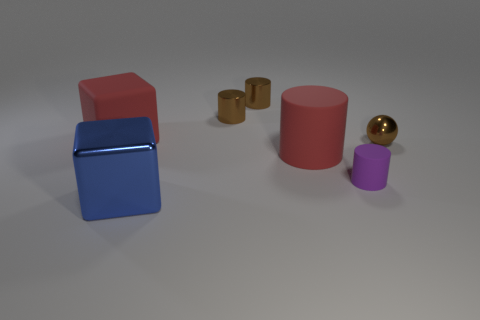Add 1 red cubes. How many objects exist? 8 Subtract all spheres. How many objects are left? 6 Subtract all large blue metal objects. Subtract all red matte blocks. How many objects are left? 5 Add 5 shiny things. How many shiny things are left? 9 Add 4 matte things. How many matte things exist? 7 Subtract 1 brown balls. How many objects are left? 6 